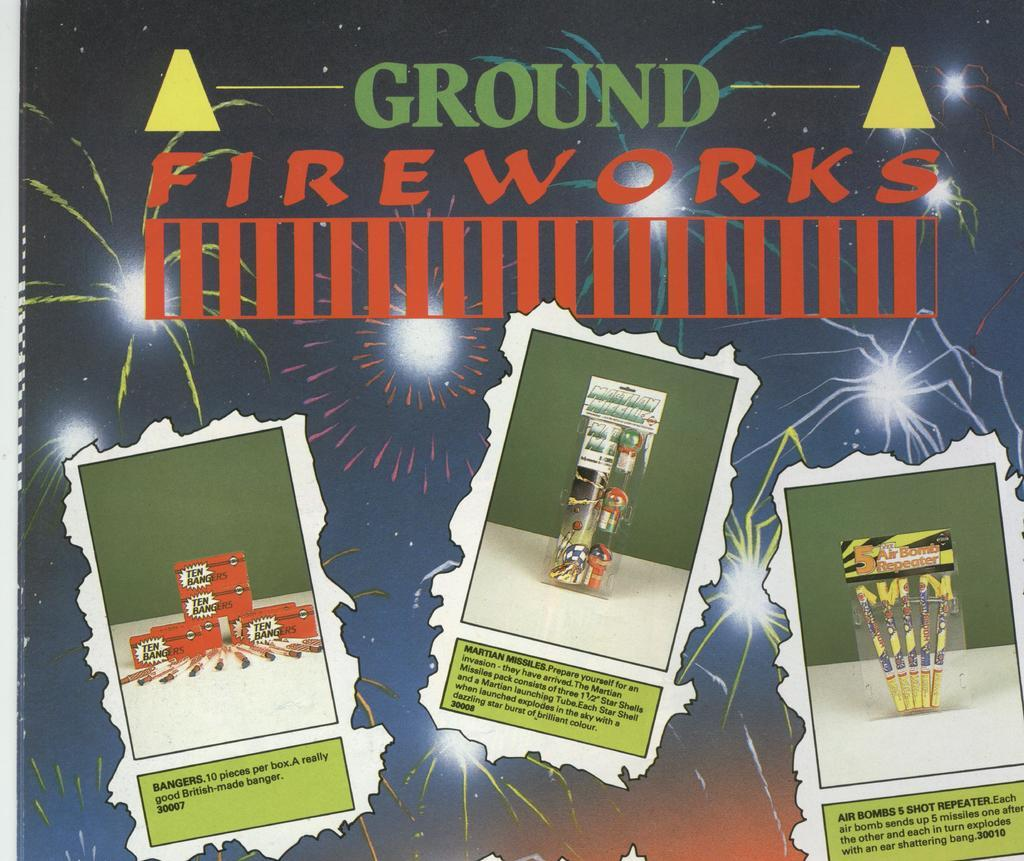<image>
Offer a succinct explanation of the picture presented. An ad showing Ground Fireworks including Air Bombs, Martian Missiles and Bangers. 